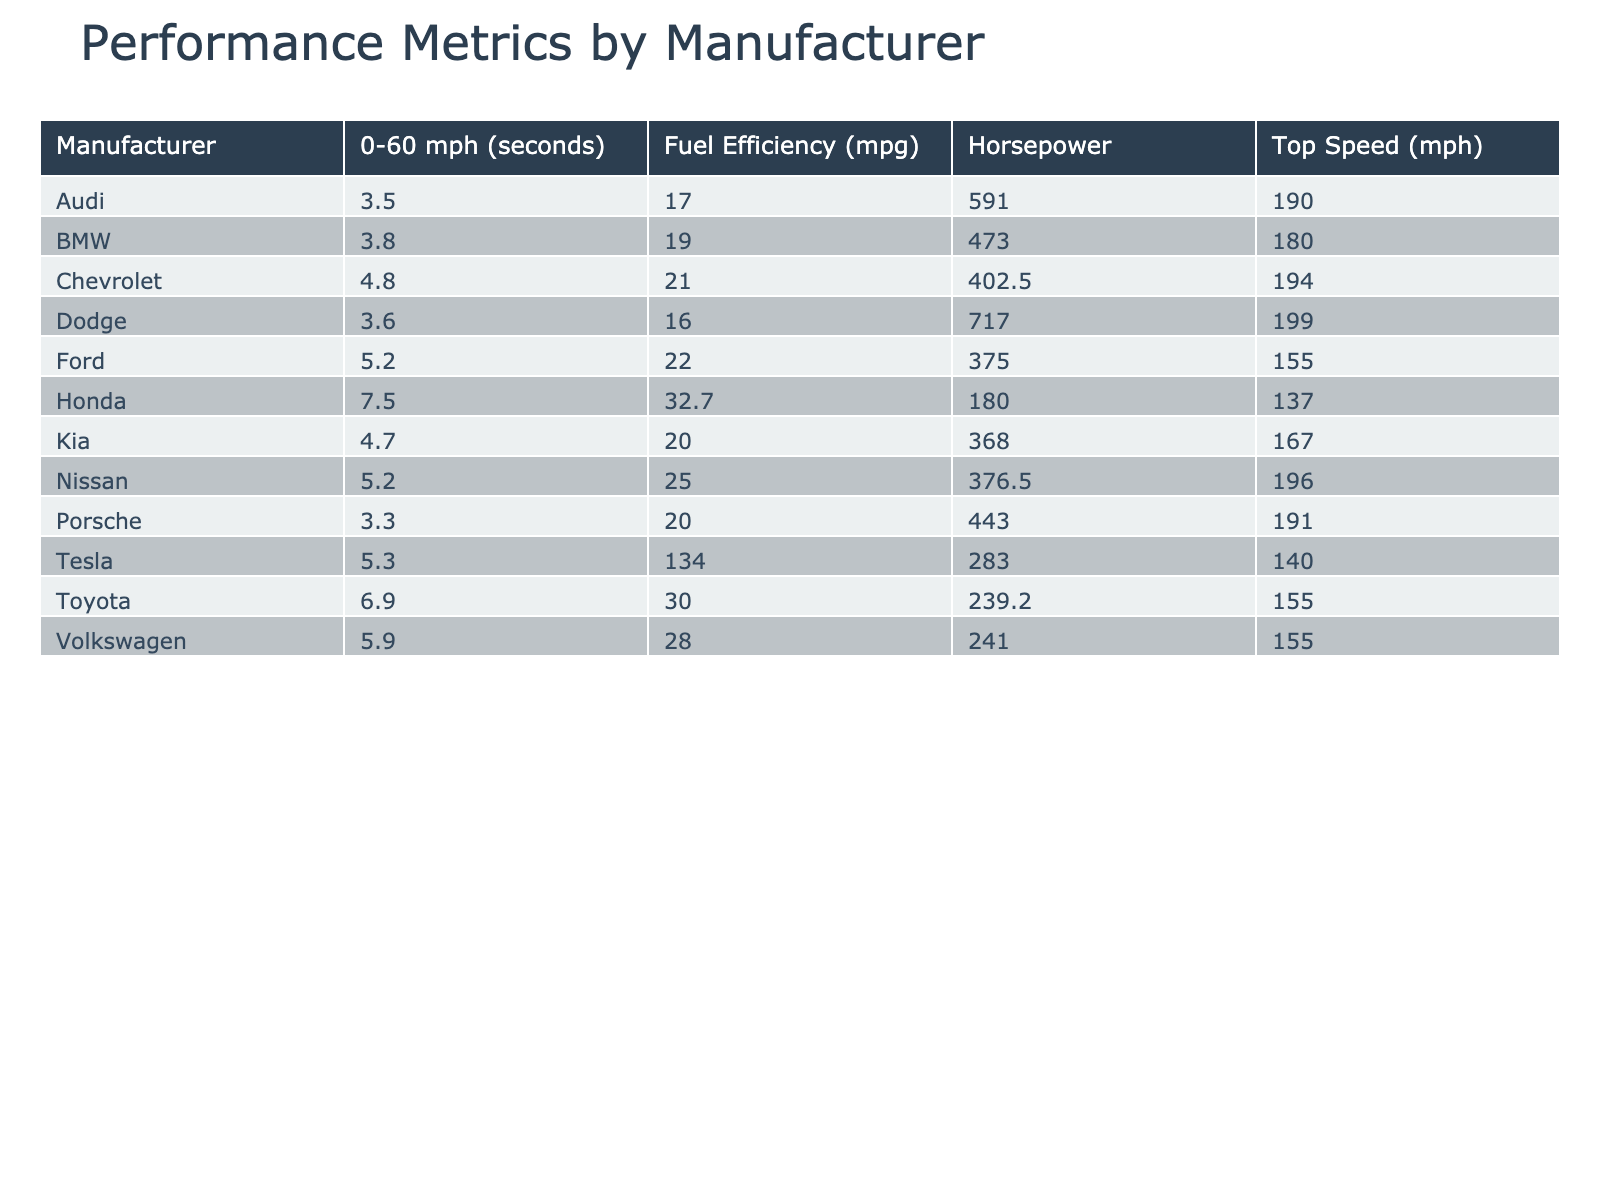What is the average horsepower of cars manufactured by Toyota? To find the average horsepower for Toyota, we can look at the horsepower values for its models in the table: 203 (Camry), 169 (Corolla), 203 (RAV4), and 382 (Supra). Summing these gives 203 + 169 + 203 + 382 = 957. Since there are 4 models, we divide by 4: 957 / 4 = 239.25, which rounds to 239.3 when considering one decimal point as in the table.
Answer: 239.3 Which manufacturer has the highest top speed? From the table, we can observe the top speeds for each manufacturer. The maximum top speed listed is 199 mph for the Dodge Challenger SRT Hellcat. Other manufacturers have lower top speeds, so Dodge holds the highest.
Answer: Dodge What is the difference in average fuel efficiency between Ford and Chevrolet? First, we need to find the average fuel efficiency for both manufacturers. For Ford, the models are F-150 (25 mpg) and Mustang GT (19 mpg), yielding an average of (25 + 19) / 2 = 22 mpg. For Chevrolet, we have Silverado (23 mpg) and C8 Corvette (19 mpg), giving an average of (23 + 19) / 2 = 21 mpg. The difference is 22 - 21 = 1 mpg.
Answer: 1 mpg Is the average 0-60 mph time for Porsche faster than that of Audi? We will calculate the average 0-60 mph time for both manufacturers: For Porsche, the only model listed is the 911 Carrera S with a time of 3.3 seconds. For Audi, there is the RS6 Avant with the same time of 3.5 seconds. Since 3.3 seconds is less than 3.5 seconds, Porsche is indeed faster on average.
Answer: Yes Which manufacturer has the highest average horsepower and how much is it? For this, we need to calculate the average horsepower for each manufacturer, then compare them. Chevrolet: (310 + 495) / 2 = 402.5, Ford: (290 + 460) / 2 = 375, Toyota: (203 + 169 + 203 + 382) / 4 = 239.3, Honda: (158 + 192 + 190) / 3 = 180. A comparison shows that Chevrolet’s average horsepower of 402.5 is the highest.
Answer: 402.5 